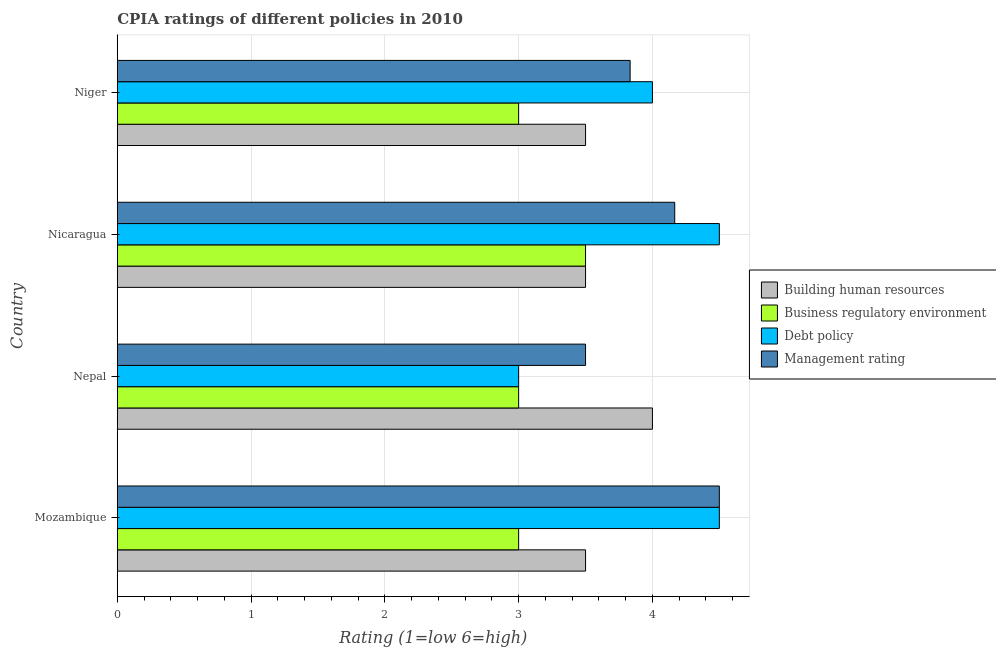How many different coloured bars are there?
Make the answer very short. 4. Are the number of bars per tick equal to the number of legend labels?
Provide a succinct answer. Yes. What is the label of the 1st group of bars from the top?
Provide a succinct answer. Niger. Across all countries, what is the maximum cpia rating of building human resources?
Provide a short and direct response. 4. In which country was the cpia rating of building human resources maximum?
Your answer should be very brief. Nepal. In which country was the cpia rating of business regulatory environment minimum?
Offer a very short reply. Mozambique. What is the difference between the cpia rating of building human resources and cpia rating of management in Nepal?
Make the answer very short. 0.5. What is the ratio of the cpia rating of business regulatory environment in Nepal to that in Niger?
Your response must be concise. 1. What is the difference between the highest and the second highest cpia rating of management?
Keep it short and to the point. 0.33. What is the difference between the highest and the lowest cpia rating of building human resources?
Offer a terse response. 0.5. Is the sum of the cpia rating of building human resources in Nepal and Nicaragua greater than the maximum cpia rating of debt policy across all countries?
Keep it short and to the point. Yes. Is it the case that in every country, the sum of the cpia rating of business regulatory environment and cpia rating of building human resources is greater than the sum of cpia rating of management and cpia rating of debt policy?
Your answer should be compact. No. What does the 2nd bar from the top in Nicaragua represents?
Keep it short and to the point. Debt policy. What does the 2nd bar from the bottom in Nepal represents?
Offer a very short reply. Business regulatory environment. Is it the case that in every country, the sum of the cpia rating of building human resources and cpia rating of business regulatory environment is greater than the cpia rating of debt policy?
Provide a succinct answer. Yes. What is the difference between two consecutive major ticks on the X-axis?
Provide a succinct answer. 1. Are the values on the major ticks of X-axis written in scientific E-notation?
Your answer should be very brief. No. Does the graph contain grids?
Offer a terse response. Yes. How many legend labels are there?
Offer a terse response. 4. How are the legend labels stacked?
Give a very brief answer. Vertical. What is the title of the graph?
Offer a very short reply. CPIA ratings of different policies in 2010. Does "Periodicity assessment" appear as one of the legend labels in the graph?
Ensure brevity in your answer.  No. What is the Rating (1=low 6=high) of Building human resources in Mozambique?
Keep it short and to the point. 3.5. What is the Rating (1=low 6=high) of Debt policy in Mozambique?
Your response must be concise. 4.5. What is the Rating (1=low 6=high) in Building human resources in Nepal?
Your response must be concise. 4. What is the Rating (1=low 6=high) of Management rating in Nepal?
Your answer should be very brief. 3.5. What is the Rating (1=low 6=high) of Building human resources in Nicaragua?
Offer a terse response. 3.5. What is the Rating (1=low 6=high) in Business regulatory environment in Nicaragua?
Make the answer very short. 3.5. What is the Rating (1=low 6=high) in Management rating in Nicaragua?
Provide a succinct answer. 4.17. What is the Rating (1=low 6=high) in Building human resources in Niger?
Provide a succinct answer. 3.5. What is the Rating (1=low 6=high) in Business regulatory environment in Niger?
Your answer should be very brief. 3. What is the Rating (1=low 6=high) in Debt policy in Niger?
Give a very brief answer. 4. What is the Rating (1=low 6=high) of Management rating in Niger?
Provide a succinct answer. 3.83. Across all countries, what is the maximum Rating (1=low 6=high) in Building human resources?
Offer a very short reply. 4. Across all countries, what is the minimum Rating (1=low 6=high) in Debt policy?
Offer a very short reply. 3. Across all countries, what is the minimum Rating (1=low 6=high) of Management rating?
Your answer should be compact. 3.5. What is the total Rating (1=low 6=high) in Building human resources in the graph?
Provide a short and direct response. 14.5. What is the total Rating (1=low 6=high) in Business regulatory environment in the graph?
Your answer should be very brief. 12.5. What is the total Rating (1=low 6=high) in Management rating in the graph?
Provide a short and direct response. 16. What is the difference between the Rating (1=low 6=high) in Building human resources in Mozambique and that in Nepal?
Keep it short and to the point. -0.5. What is the difference between the Rating (1=low 6=high) of Debt policy in Mozambique and that in Nepal?
Offer a very short reply. 1.5. What is the difference between the Rating (1=low 6=high) in Management rating in Mozambique and that in Nepal?
Your answer should be very brief. 1. What is the difference between the Rating (1=low 6=high) of Building human resources in Mozambique and that in Nicaragua?
Provide a succinct answer. 0. What is the difference between the Rating (1=low 6=high) of Business regulatory environment in Mozambique and that in Nicaragua?
Your response must be concise. -0.5. What is the difference between the Rating (1=low 6=high) of Building human resources in Mozambique and that in Niger?
Ensure brevity in your answer.  0. What is the difference between the Rating (1=low 6=high) in Business regulatory environment in Mozambique and that in Niger?
Make the answer very short. 0. What is the difference between the Rating (1=low 6=high) in Management rating in Mozambique and that in Niger?
Offer a terse response. 0.67. What is the difference between the Rating (1=low 6=high) of Management rating in Nepal and that in Nicaragua?
Your answer should be compact. -0.67. What is the difference between the Rating (1=low 6=high) in Debt policy in Nepal and that in Niger?
Make the answer very short. -1. What is the difference between the Rating (1=low 6=high) of Management rating in Nicaragua and that in Niger?
Ensure brevity in your answer.  0.33. What is the difference between the Rating (1=low 6=high) of Building human resources in Mozambique and the Rating (1=low 6=high) of Business regulatory environment in Nepal?
Provide a short and direct response. 0.5. What is the difference between the Rating (1=low 6=high) of Building human resources in Mozambique and the Rating (1=low 6=high) of Debt policy in Nepal?
Ensure brevity in your answer.  0.5. What is the difference between the Rating (1=low 6=high) in Building human resources in Mozambique and the Rating (1=low 6=high) in Management rating in Nepal?
Your response must be concise. 0. What is the difference between the Rating (1=low 6=high) in Business regulatory environment in Mozambique and the Rating (1=low 6=high) in Management rating in Nepal?
Ensure brevity in your answer.  -0.5. What is the difference between the Rating (1=low 6=high) in Debt policy in Mozambique and the Rating (1=low 6=high) in Management rating in Nepal?
Your response must be concise. 1. What is the difference between the Rating (1=low 6=high) in Building human resources in Mozambique and the Rating (1=low 6=high) in Business regulatory environment in Nicaragua?
Your answer should be compact. 0. What is the difference between the Rating (1=low 6=high) in Business regulatory environment in Mozambique and the Rating (1=low 6=high) in Management rating in Nicaragua?
Provide a succinct answer. -1.17. What is the difference between the Rating (1=low 6=high) of Debt policy in Mozambique and the Rating (1=low 6=high) of Management rating in Nicaragua?
Your answer should be compact. 0.33. What is the difference between the Rating (1=low 6=high) in Business regulatory environment in Mozambique and the Rating (1=low 6=high) in Debt policy in Niger?
Offer a very short reply. -1. What is the difference between the Rating (1=low 6=high) of Business regulatory environment in Mozambique and the Rating (1=low 6=high) of Management rating in Niger?
Ensure brevity in your answer.  -0.83. What is the difference between the Rating (1=low 6=high) of Building human resources in Nepal and the Rating (1=low 6=high) of Debt policy in Nicaragua?
Provide a succinct answer. -0.5. What is the difference between the Rating (1=low 6=high) of Business regulatory environment in Nepal and the Rating (1=low 6=high) of Management rating in Nicaragua?
Your answer should be very brief. -1.17. What is the difference between the Rating (1=low 6=high) of Debt policy in Nepal and the Rating (1=low 6=high) of Management rating in Nicaragua?
Your answer should be very brief. -1.17. What is the difference between the Rating (1=low 6=high) in Building human resources in Nepal and the Rating (1=low 6=high) in Debt policy in Niger?
Your answer should be very brief. 0. What is the difference between the Rating (1=low 6=high) in Building human resources in Nepal and the Rating (1=low 6=high) in Management rating in Niger?
Provide a succinct answer. 0.17. What is the difference between the Rating (1=low 6=high) of Business regulatory environment in Nepal and the Rating (1=low 6=high) of Debt policy in Niger?
Offer a terse response. -1. What is the difference between the Rating (1=low 6=high) in Business regulatory environment in Nepal and the Rating (1=low 6=high) in Management rating in Niger?
Provide a succinct answer. -0.83. What is the difference between the Rating (1=low 6=high) of Debt policy in Nepal and the Rating (1=low 6=high) of Management rating in Niger?
Your response must be concise. -0.83. What is the difference between the Rating (1=low 6=high) of Building human resources in Nicaragua and the Rating (1=low 6=high) of Debt policy in Niger?
Provide a succinct answer. -0.5. What is the difference between the Rating (1=low 6=high) in Debt policy in Nicaragua and the Rating (1=low 6=high) in Management rating in Niger?
Provide a short and direct response. 0.67. What is the average Rating (1=low 6=high) of Building human resources per country?
Provide a short and direct response. 3.62. What is the average Rating (1=low 6=high) of Business regulatory environment per country?
Give a very brief answer. 3.12. What is the average Rating (1=low 6=high) in Management rating per country?
Give a very brief answer. 4. What is the difference between the Rating (1=low 6=high) in Building human resources and Rating (1=low 6=high) in Debt policy in Mozambique?
Your answer should be very brief. -1. What is the difference between the Rating (1=low 6=high) in Building human resources and Rating (1=low 6=high) in Management rating in Mozambique?
Provide a succinct answer. -1. What is the difference between the Rating (1=low 6=high) in Business regulatory environment and Rating (1=low 6=high) in Debt policy in Mozambique?
Your answer should be very brief. -1.5. What is the difference between the Rating (1=low 6=high) in Business regulatory environment and Rating (1=low 6=high) in Management rating in Mozambique?
Make the answer very short. -1.5. What is the difference between the Rating (1=low 6=high) of Building human resources and Rating (1=low 6=high) of Management rating in Nepal?
Keep it short and to the point. 0.5. What is the difference between the Rating (1=low 6=high) in Business regulatory environment and Rating (1=low 6=high) in Management rating in Nepal?
Your answer should be compact. -0.5. What is the difference between the Rating (1=low 6=high) of Debt policy and Rating (1=low 6=high) of Management rating in Nepal?
Ensure brevity in your answer.  -0.5. What is the difference between the Rating (1=low 6=high) of Building human resources and Rating (1=low 6=high) of Business regulatory environment in Nicaragua?
Make the answer very short. 0. What is the difference between the Rating (1=low 6=high) of Building human resources and Rating (1=low 6=high) of Debt policy in Nicaragua?
Provide a succinct answer. -1. What is the difference between the Rating (1=low 6=high) in Business regulatory environment and Rating (1=low 6=high) in Debt policy in Nicaragua?
Make the answer very short. -1. What is the difference between the Rating (1=low 6=high) of Business regulatory environment and Rating (1=low 6=high) of Management rating in Nicaragua?
Your answer should be very brief. -0.67. What is the difference between the Rating (1=low 6=high) in Debt policy and Rating (1=low 6=high) in Management rating in Nicaragua?
Your answer should be compact. 0.33. What is the difference between the Rating (1=low 6=high) of Building human resources and Rating (1=low 6=high) of Debt policy in Niger?
Provide a succinct answer. -0.5. What is the difference between the Rating (1=low 6=high) of Business regulatory environment and Rating (1=low 6=high) of Debt policy in Niger?
Ensure brevity in your answer.  -1. What is the difference between the Rating (1=low 6=high) in Debt policy and Rating (1=low 6=high) in Management rating in Niger?
Your response must be concise. 0.17. What is the ratio of the Rating (1=low 6=high) of Building human resources in Mozambique to that in Nicaragua?
Your answer should be very brief. 1. What is the ratio of the Rating (1=low 6=high) of Business regulatory environment in Mozambique to that in Nicaragua?
Your answer should be very brief. 0.86. What is the ratio of the Rating (1=low 6=high) of Debt policy in Mozambique to that in Nicaragua?
Make the answer very short. 1. What is the ratio of the Rating (1=low 6=high) of Management rating in Mozambique to that in Nicaragua?
Give a very brief answer. 1.08. What is the ratio of the Rating (1=low 6=high) in Building human resources in Mozambique to that in Niger?
Make the answer very short. 1. What is the ratio of the Rating (1=low 6=high) in Business regulatory environment in Mozambique to that in Niger?
Ensure brevity in your answer.  1. What is the ratio of the Rating (1=low 6=high) in Management rating in Mozambique to that in Niger?
Ensure brevity in your answer.  1.17. What is the ratio of the Rating (1=low 6=high) of Building human resources in Nepal to that in Nicaragua?
Provide a succinct answer. 1.14. What is the ratio of the Rating (1=low 6=high) in Management rating in Nepal to that in Nicaragua?
Provide a succinct answer. 0.84. What is the ratio of the Rating (1=low 6=high) of Building human resources in Nepal to that in Niger?
Your answer should be compact. 1.14. What is the ratio of the Rating (1=low 6=high) of Management rating in Nepal to that in Niger?
Make the answer very short. 0.91. What is the ratio of the Rating (1=low 6=high) in Building human resources in Nicaragua to that in Niger?
Give a very brief answer. 1. What is the ratio of the Rating (1=low 6=high) in Business regulatory environment in Nicaragua to that in Niger?
Offer a very short reply. 1.17. What is the ratio of the Rating (1=low 6=high) in Management rating in Nicaragua to that in Niger?
Your response must be concise. 1.09. What is the difference between the highest and the second highest Rating (1=low 6=high) in Business regulatory environment?
Your response must be concise. 0.5. What is the difference between the highest and the second highest Rating (1=low 6=high) in Debt policy?
Ensure brevity in your answer.  0. What is the difference between the highest and the second highest Rating (1=low 6=high) in Management rating?
Your response must be concise. 0.33. What is the difference between the highest and the lowest Rating (1=low 6=high) in Building human resources?
Your answer should be very brief. 0.5. What is the difference between the highest and the lowest Rating (1=low 6=high) of Business regulatory environment?
Ensure brevity in your answer.  0.5. 